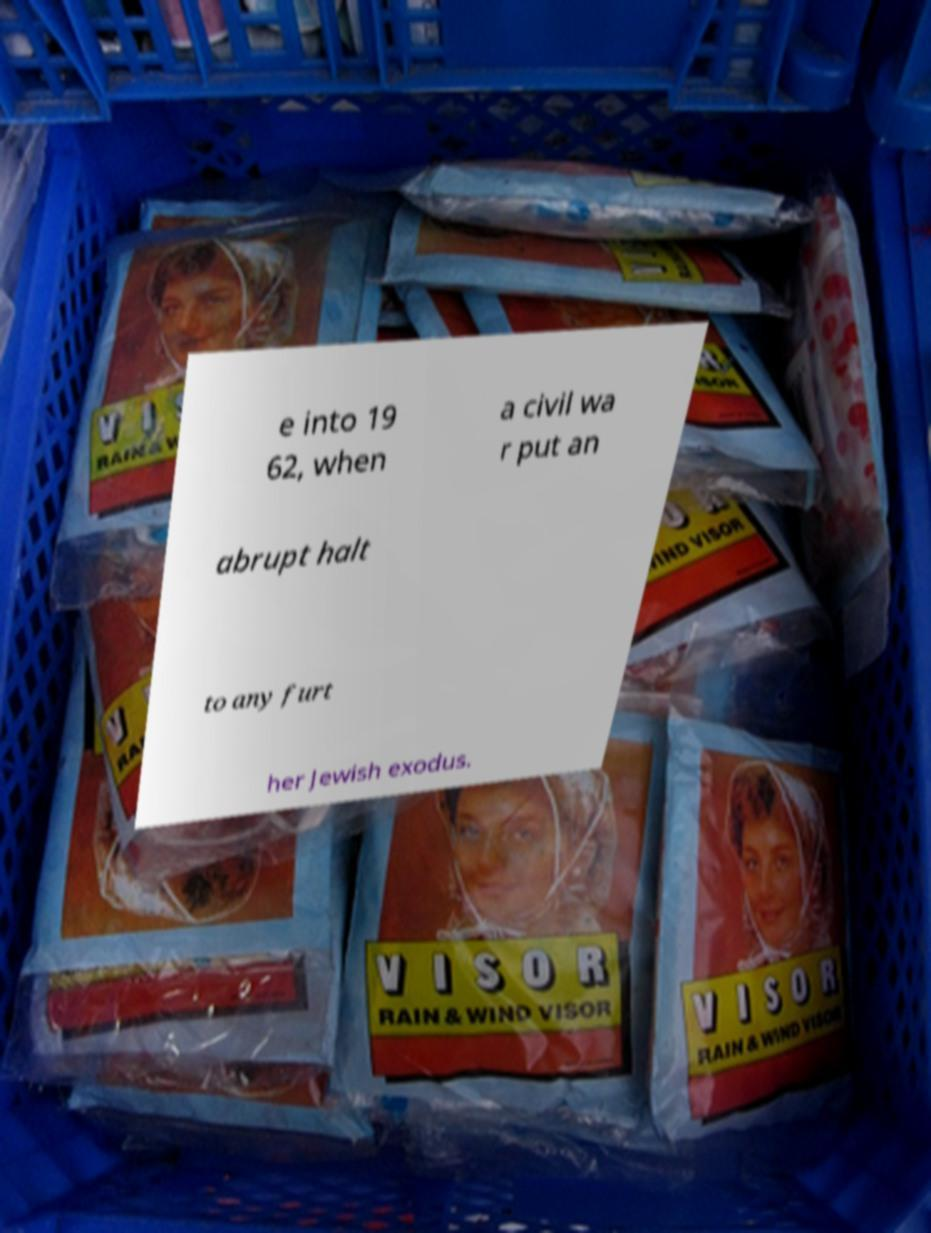Could you extract and type out the text from this image? e into 19 62, when a civil wa r put an abrupt halt to any furt her Jewish exodus. 